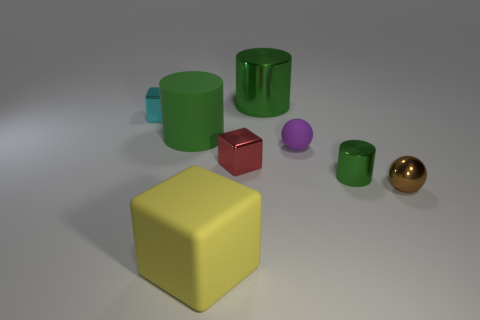What object stands out the most in this image? The yellow cube stands out the most due to its bright color and prominent placement in the foreground of the image. Its sizable volume compared to the other objects also draws the viewer's attention. 